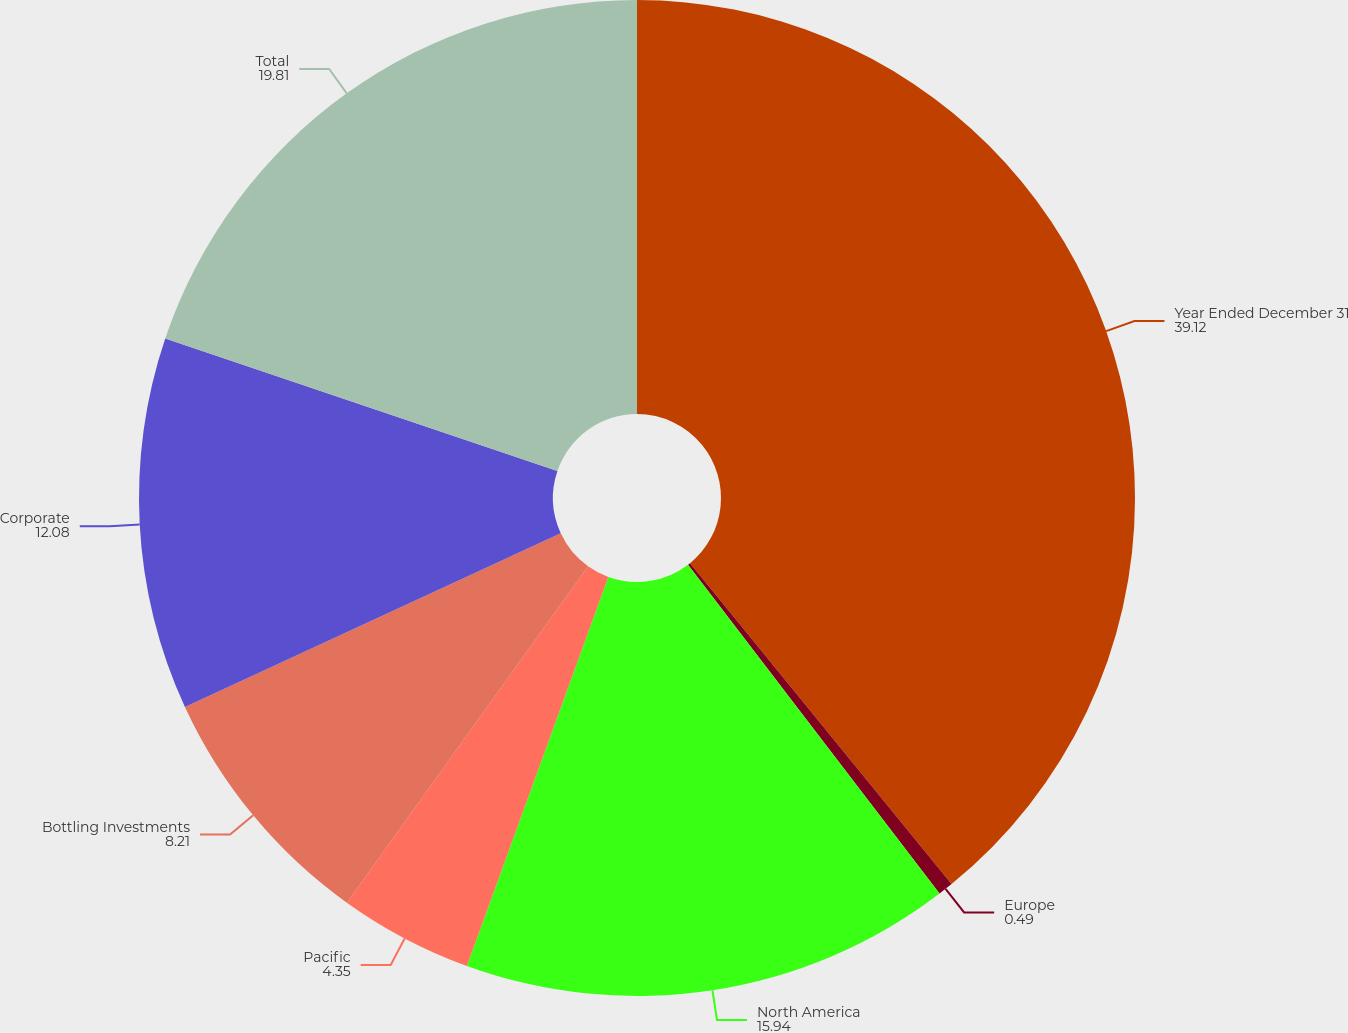Convert chart to OTSL. <chart><loc_0><loc_0><loc_500><loc_500><pie_chart><fcel>Year Ended December 31<fcel>Europe<fcel>North America<fcel>Pacific<fcel>Bottling Investments<fcel>Corporate<fcel>Total<nl><fcel>39.12%<fcel>0.49%<fcel>15.94%<fcel>4.35%<fcel>8.21%<fcel>12.08%<fcel>19.81%<nl></chart> 